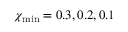Convert formula to latex. <formula><loc_0><loc_0><loc_500><loc_500>\chi _ { \min } = 0 . 3 , 0 . 2 , 0 . 1</formula> 